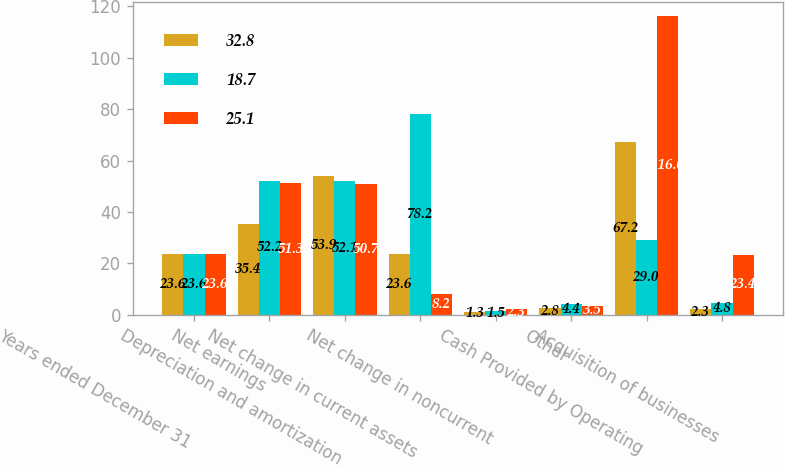Convert chart to OTSL. <chart><loc_0><loc_0><loc_500><loc_500><stacked_bar_chart><ecel><fcel>Years ended December 31<fcel>Net earnings<fcel>Depreciation and amortization<fcel>Net change in current assets<fcel>Net change in noncurrent<fcel>Other<fcel>Cash Provided by Operating<fcel>Acquisition of businesses<nl><fcel>32.8<fcel>23.6<fcel>35.4<fcel>53.9<fcel>23.6<fcel>1.3<fcel>2.8<fcel>67.2<fcel>2.3<nl><fcel>18.7<fcel>23.6<fcel>52.2<fcel>52.1<fcel>78.2<fcel>1.5<fcel>4.4<fcel>29<fcel>4.8<nl><fcel>25.1<fcel>23.6<fcel>51.3<fcel>50.7<fcel>8.2<fcel>2.3<fcel>3.5<fcel>116<fcel>23.4<nl></chart> 